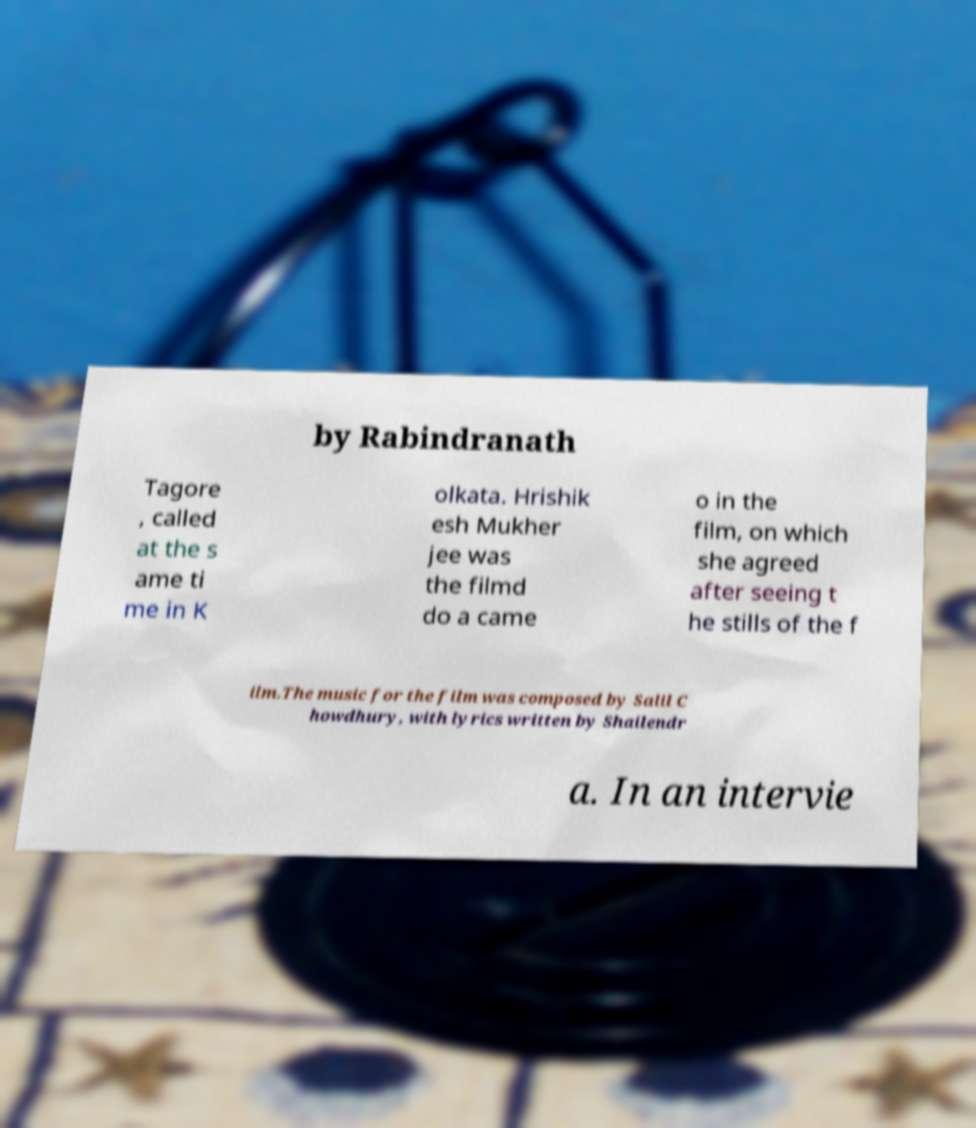Please read and relay the text visible in this image. What does it say? by Rabindranath Tagore , called at the s ame ti me in K olkata. Hrishik esh Mukher jee was the filmd do a came o in the film, on which she agreed after seeing t he stills of the f ilm.The music for the film was composed by Salil C howdhury, with lyrics written by Shailendr a. In an intervie 